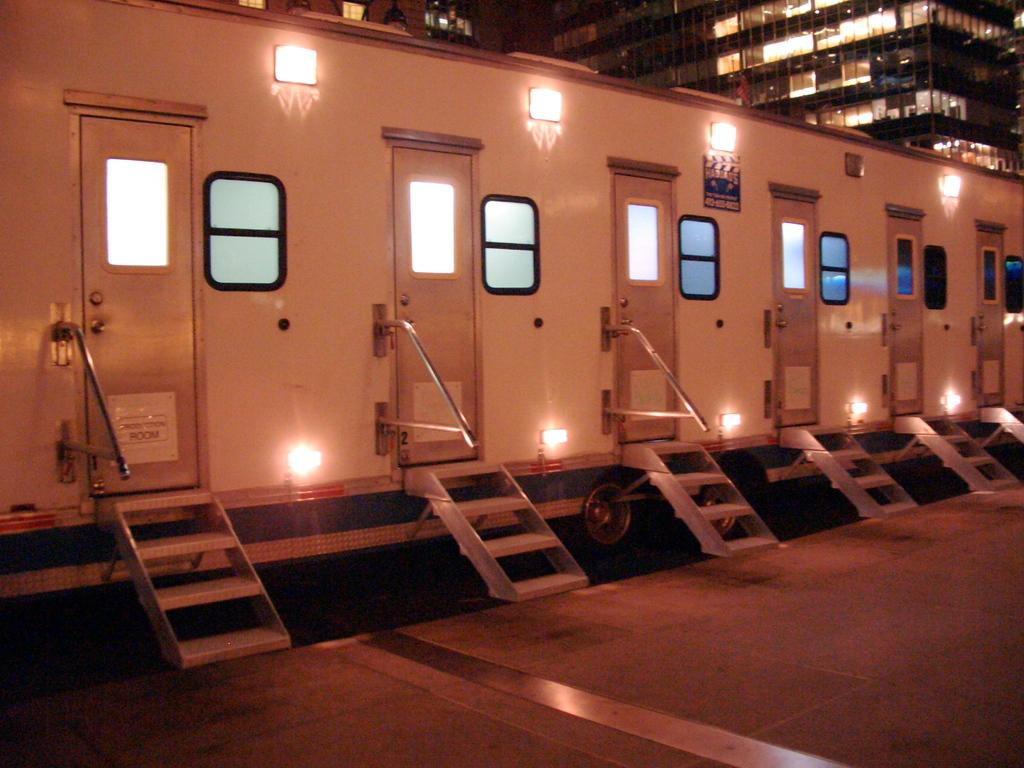What is the main subject in the center of the image? There is a train in the center of the image. What can be seen illuminated in the image? There are lights visible in the image. What type of structures are visible in the background? There are buildings in the background of the image. What surface is visible at the bottom of the image? There is a floor visible at the bottom of the image. How many babies are crawling on the train in the image? There are no babies present in the image, and they are not crawling on the train. 